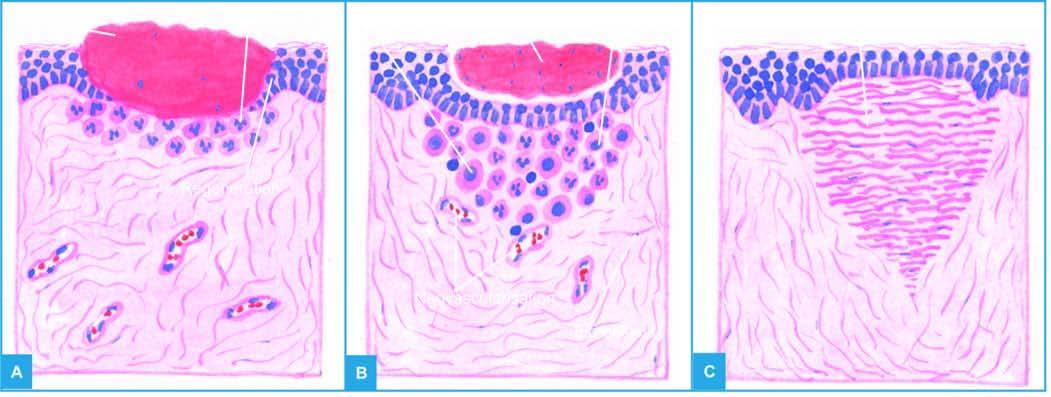where is inflammatory response?
Answer the question using a single word or phrase. At the junction of viable tissue 